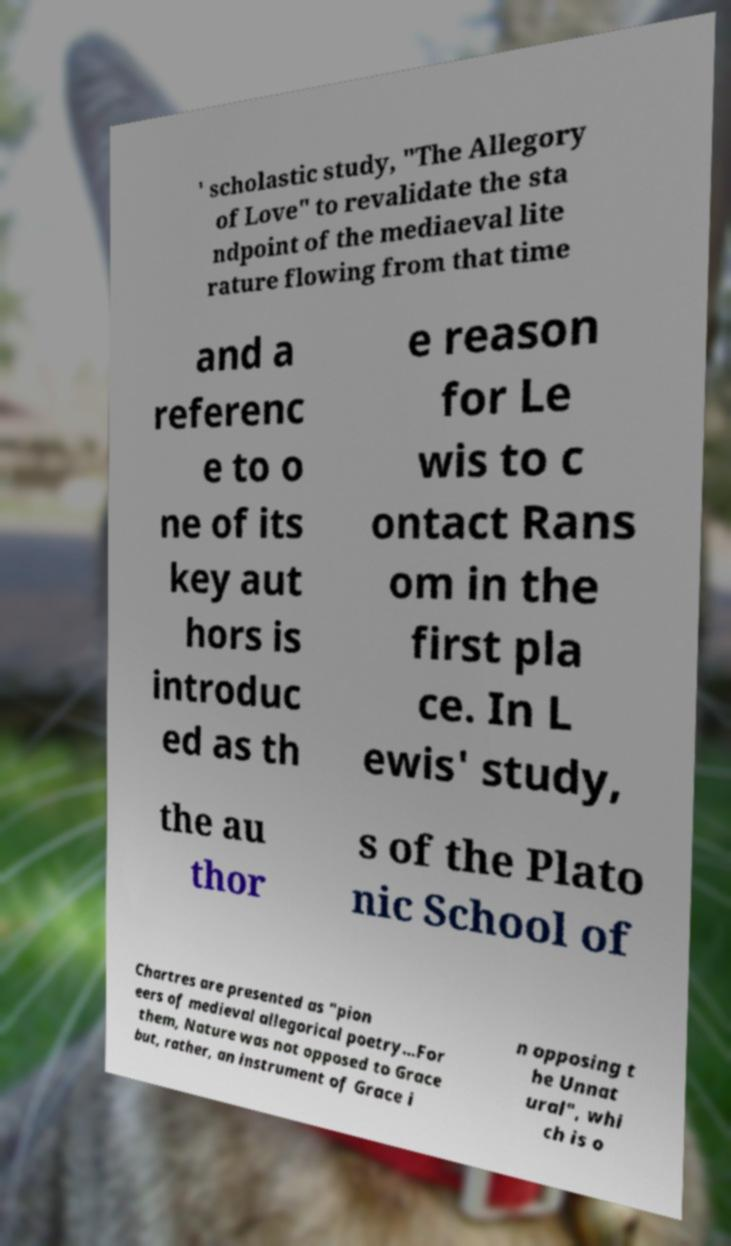Please read and relay the text visible in this image. What does it say? ' scholastic study, "The Allegory of Love" to revalidate the sta ndpoint of the mediaeval lite rature flowing from that time and a referenc e to o ne of its key aut hors is introduc ed as th e reason for Le wis to c ontact Rans om in the first pla ce. In L ewis' study, the au thor s of the Plato nic School of Chartres are presented as "pion eers of medieval allegorical poetry…For them, Nature was not opposed to Grace but, rather, an instrument of Grace i n opposing t he Unnat ural", whi ch is o 